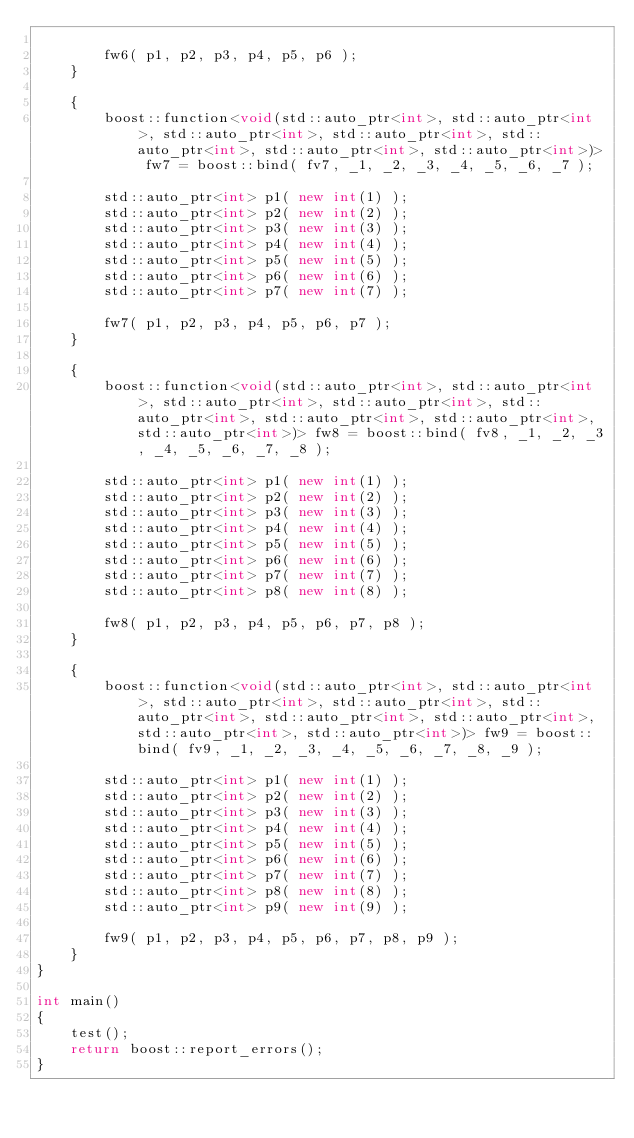Convert code to text. <code><loc_0><loc_0><loc_500><loc_500><_C++_>
        fw6( p1, p2, p3, p4, p5, p6 );
    }

    {
        boost::function<void(std::auto_ptr<int>, std::auto_ptr<int>, std::auto_ptr<int>, std::auto_ptr<int>, std::auto_ptr<int>, std::auto_ptr<int>, std::auto_ptr<int>)> fw7 = boost::bind( fv7, _1, _2, _3, _4, _5, _6, _7 );

        std::auto_ptr<int> p1( new int(1) );
        std::auto_ptr<int> p2( new int(2) );
        std::auto_ptr<int> p3( new int(3) );
        std::auto_ptr<int> p4( new int(4) );
        std::auto_ptr<int> p5( new int(5) );
        std::auto_ptr<int> p6( new int(6) );
        std::auto_ptr<int> p7( new int(7) );

        fw7( p1, p2, p3, p4, p5, p6, p7 );
    }

    {
        boost::function<void(std::auto_ptr<int>, std::auto_ptr<int>, std::auto_ptr<int>, std::auto_ptr<int>, std::auto_ptr<int>, std::auto_ptr<int>, std::auto_ptr<int>, std::auto_ptr<int>)> fw8 = boost::bind( fv8, _1, _2, _3, _4, _5, _6, _7, _8 );

        std::auto_ptr<int> p1( new int(1) );
        std::auto_ptr<int> p2( new int(2) );
        std::auto_ptr<int> p3( new int(3) );
        std::auto_ptr<int> p4( new int(4) );
        std::auto_ptr<int> p5( new int(5) );
        std::auto_ptr<int> p6( new int(6) );
        std::auto_ptr<int> p7( new int(7) );
        std::auto_ptr<int> p8( new int(8) );

        fw8( p1, p2, p3, p4, p5, p6, p7, p8 );
    }

    {
        boost::function<void(std::auto_ptr<int>, std::auto_ptr<int>, std::auto_ptr<int>, std::auto_ptr<int>, std::auto_ptr<int>, std::auto_ptr<int>, std::auto_ptr<int>, std::auto_ptr<int>, std::auto_ptr<int>)> fw9 = boost::bind( fv9, _1, _2, _3, _4, _5, _6, _7, _8, _9 );

        std::auto_ptr<int> p1( new int(1) );
        std::auto_ptr<int> p2( new int(2) );
        std::auto_ptr<int> p3( new int(3) );
        std::auto_ptr<int> p4( new int(4) );
        std::auto_ptr<int> p5( new int(5) );
        std::auto_ptr<int> p6( new int(6) );
        std::auto_ptr<int> p7( new int(7) );
        std::auto_ptr<int> p8( new int(8) );
        std::auto_ptr<int> p9( new int(9) );

        fw9( p1, p2, p3, p4, p5, p6, p7, p8, p9 );
    }
}

int main()
{
    test();
    return boost::report_errors();
}
</code> 